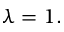<formula> <loc_0><loc_0><loc_500><loc_500>\lambda = 1 .</formula> 